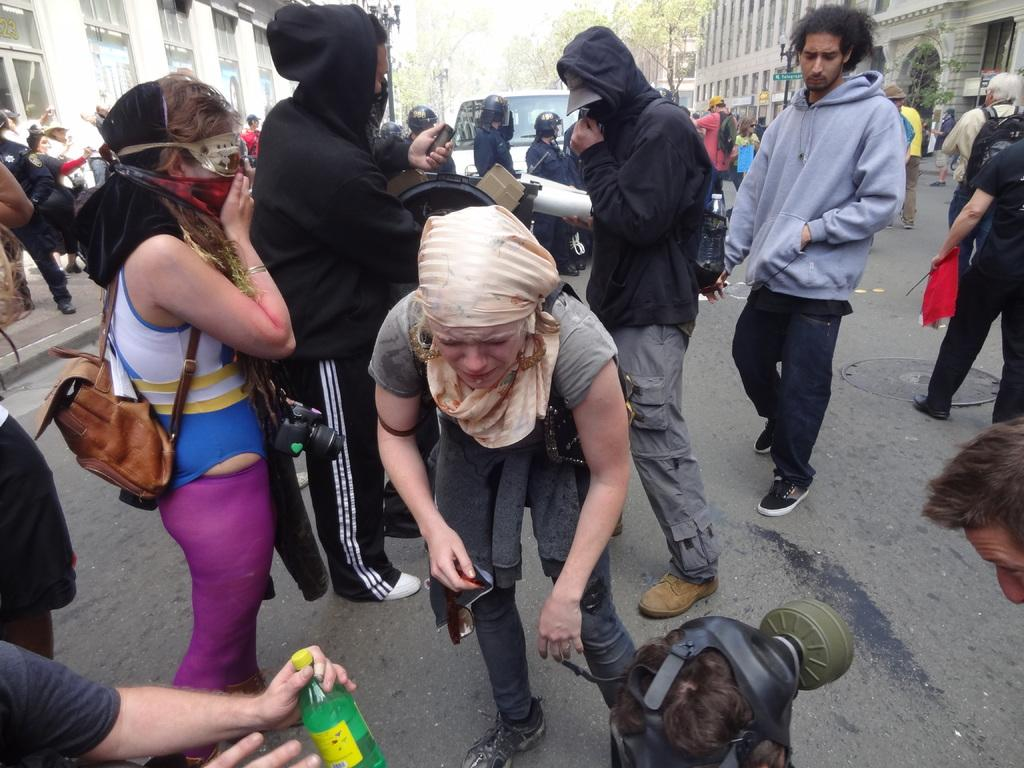What are the people in the image doing? The people in the image are standing on the road. What can be seen in the background of the image? There is a vehicle, poles, buildings, and trees visible in the background. What scent can be detected from the donkey in the image? There is no donkey present in the image, so it is not possible to determine any scent. 